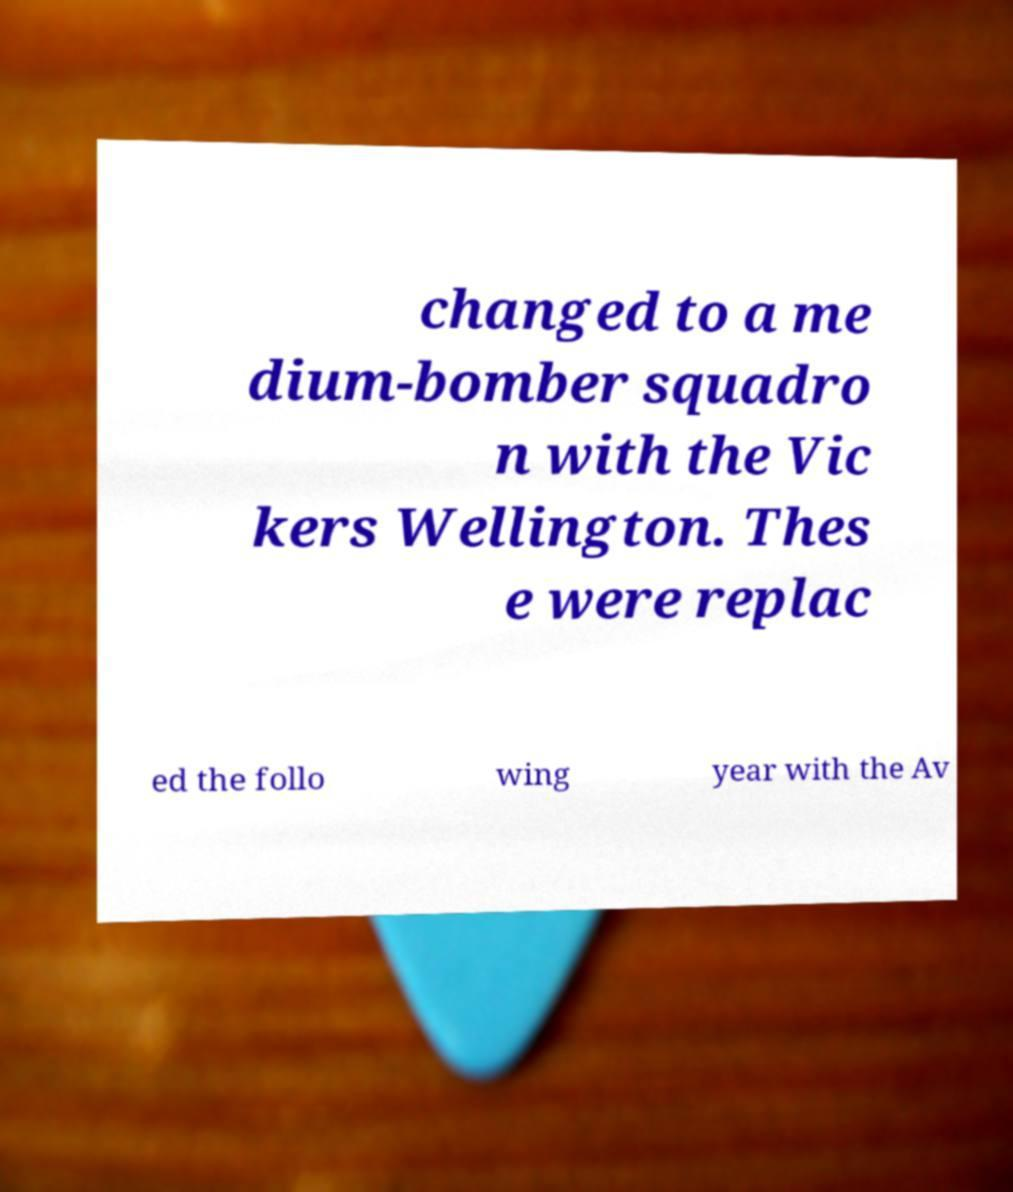Please read and relay the text visible in this image. What does it say? changed to a me dium-bomber squadro n with the Vic kers Wellington. Thes e were replac ed the follo wing year with the Av 